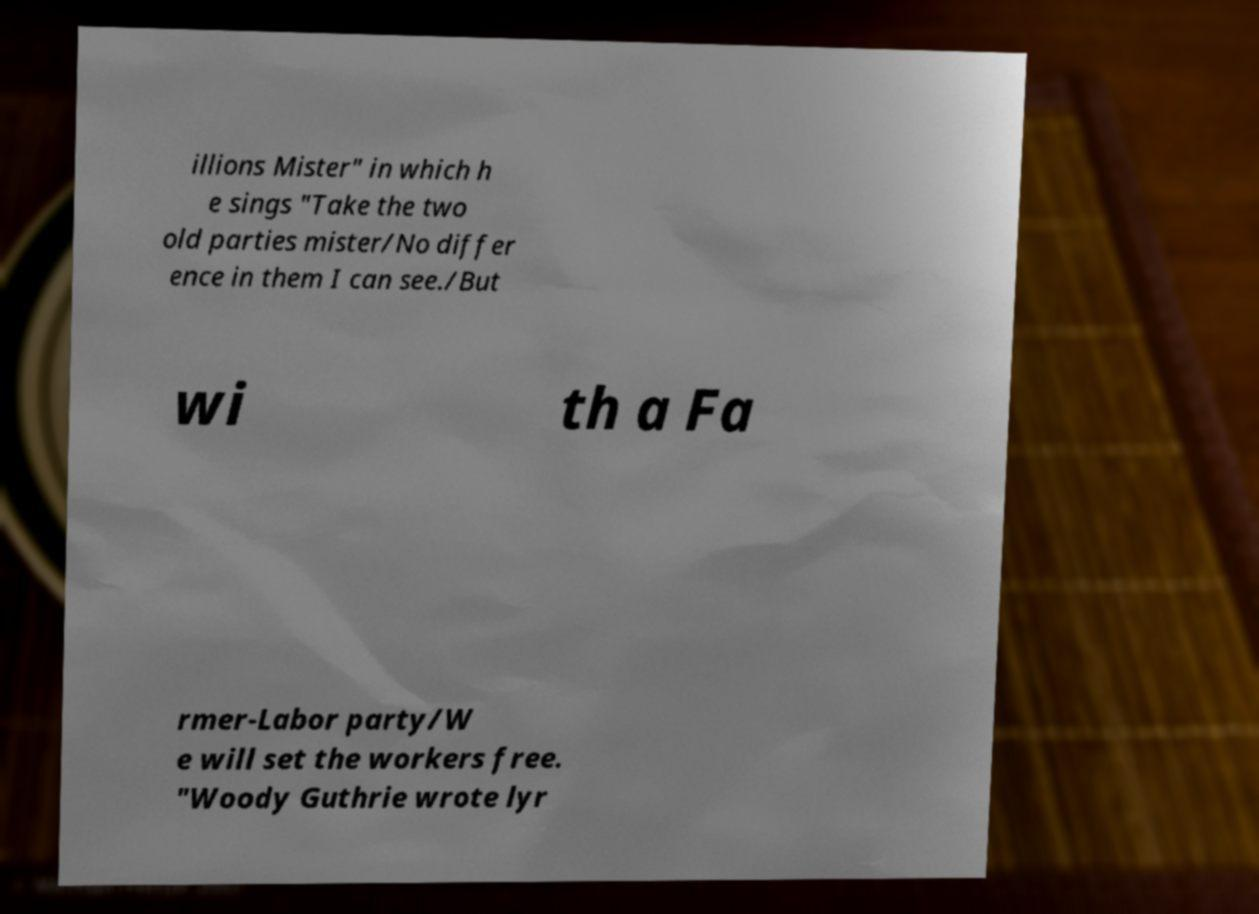Can you accurately transcribe the text from the provided image for me? illions Mister" in which h e sings "Take the two old parties mister/No differ ence in them I can see./But wi th a Fa rmer-Labor party/W e will set the workers free. "Woody Guthrie wrote lyr 